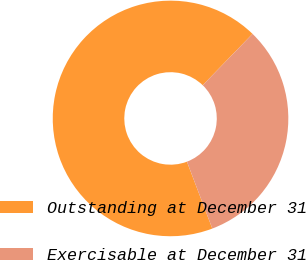<chart> <loc_0><loc_0><loc_500><loc_500><pie_chart><fcel>Outstanding at December 31<fcel>Exercisable at December 31<nl><fcel>68.02%<fcel>31.98%<nl></chart> 